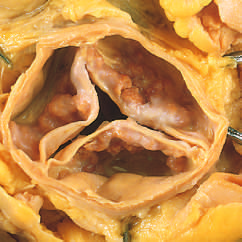what are heaped up within the sinuses of valsalva?
Answer the question using a single word or phrase. Nodular masses of calcium 